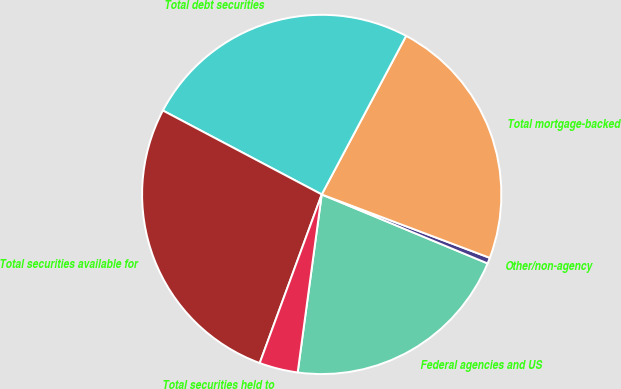Convert chart. <chart><loc_0><loc_0><loc_500><loc_500><pie_chart><fcel>Federal agencies and US<fcel>Other/non-agency<fcel>Total mortgage-backed<fcel>Total debt securities<fcel>Total securities available for<fcel>Total securities held to<nl><fcel>20.87%<fcel>0.53%<fcel>22.96%<fcel>25.05%<fcel>27.13%<fcel>3.47%<nl></chart> 